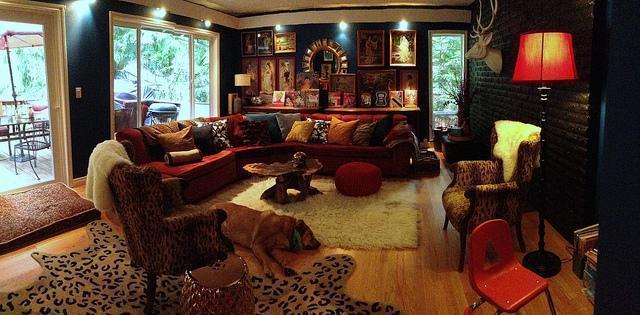What is hanging on the right side of the room?
Answer the question by selecting the correct answer among the 4 following choices and explain your choice with a short sentence. The answer should be formatted with the following format: `Answer: choice
Rationale: rationale.`
Options: Goddess statue, deer head, baseball pennant, monkey. Answer: deer head.
Rationale: There is a mounted taxidermy display of an animal that resembles the item in option a. 